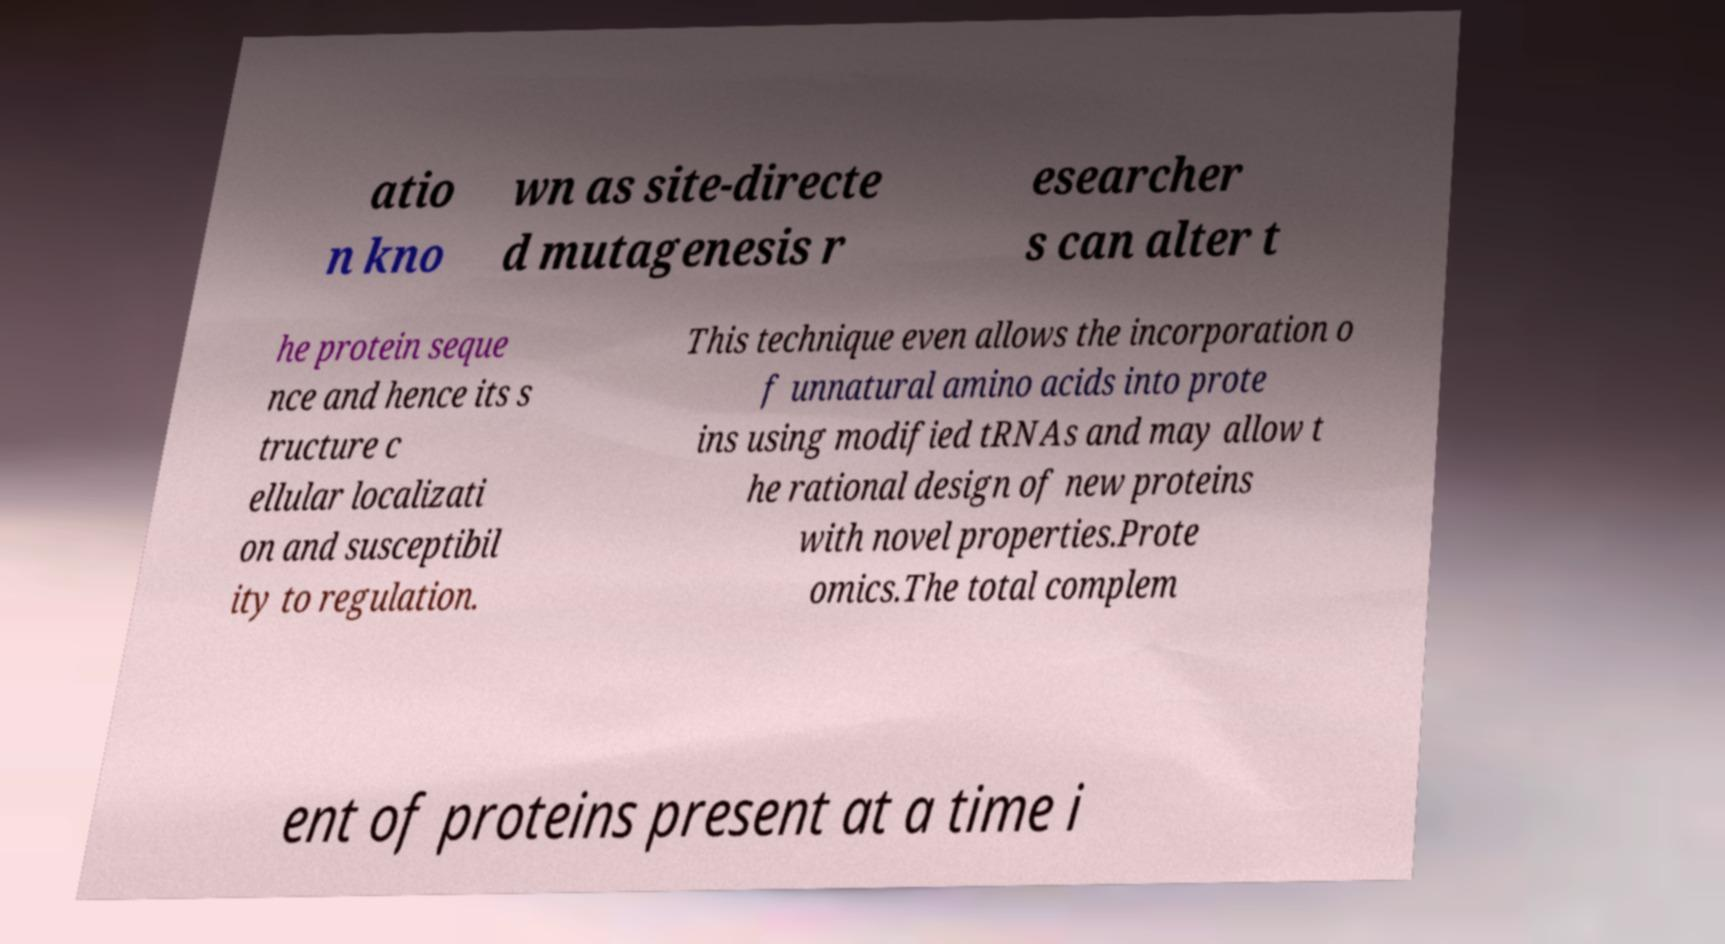Could you extract and type out the text from this image? atio n kno wn as site-directe d mutagenesis r esearcher s can alter t he protein seque nce and hence its s tructure c ellular localizati on and susceptibil ity to regulation. This technique even allows the incorporation o f unnatural amino acids into prote ins using modified tRNAs and may allow t he rational design of new proteins with novel properties.Prote omics.The total complem ent of proteins present at a time i 